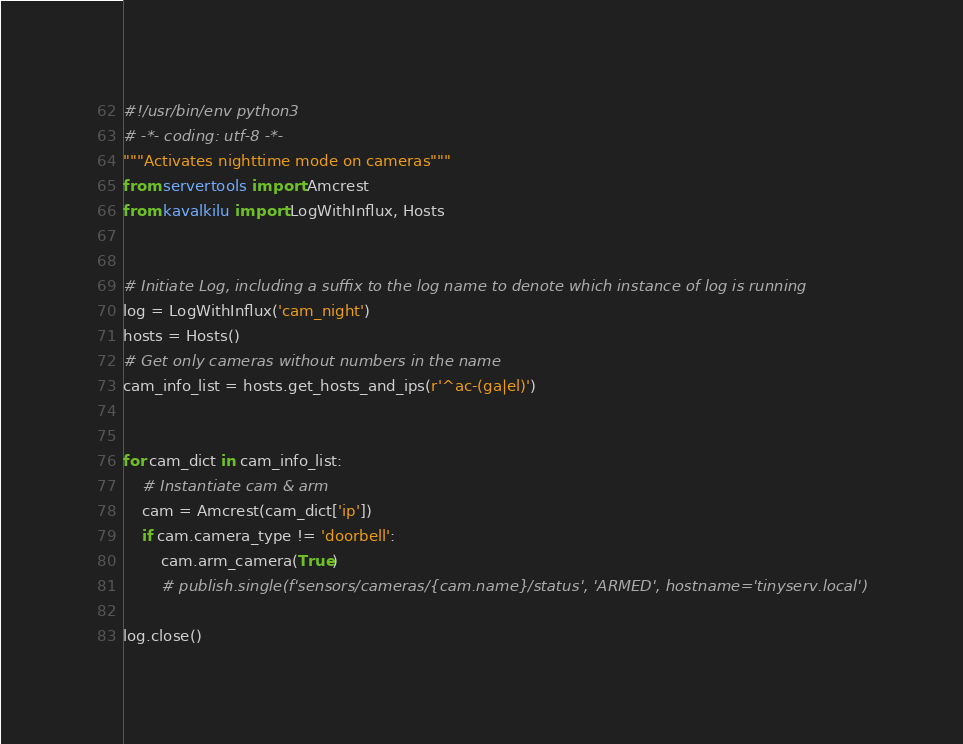Convert code to text. <code><loc_0><loc_0><loc_500><loc_500><_Python_>#!/usr/bin/env python3
# -*- coding: utf-8 -*-
"""Activates nighttime mode on cameras"""
from servertools import Amcrest
from kavalkilu import LogWithInflux, Hosts


# Initiate Log, including a suffix to the log name to denote which instance of log is running
log = LogWithInflux('cam_night')
hosts = Hosts()
# Get only cameras without numbers in the name
cam_info_list = hosts.get_hosts_and_ips(r'^ac-(ga|el)')


for cam_dict in cam_info_list:
    # Instantiate cam & arm
    cam = Amcrest(cam_dict['ip'])
    if cam.camera_type != 'doorbell':
        cam.arm_camera(True)
        # publish.single(f'sensors/cameras/{cam.name}/status', 'ARMED', hostname='tinyserv.local')

log.close()
</code> 